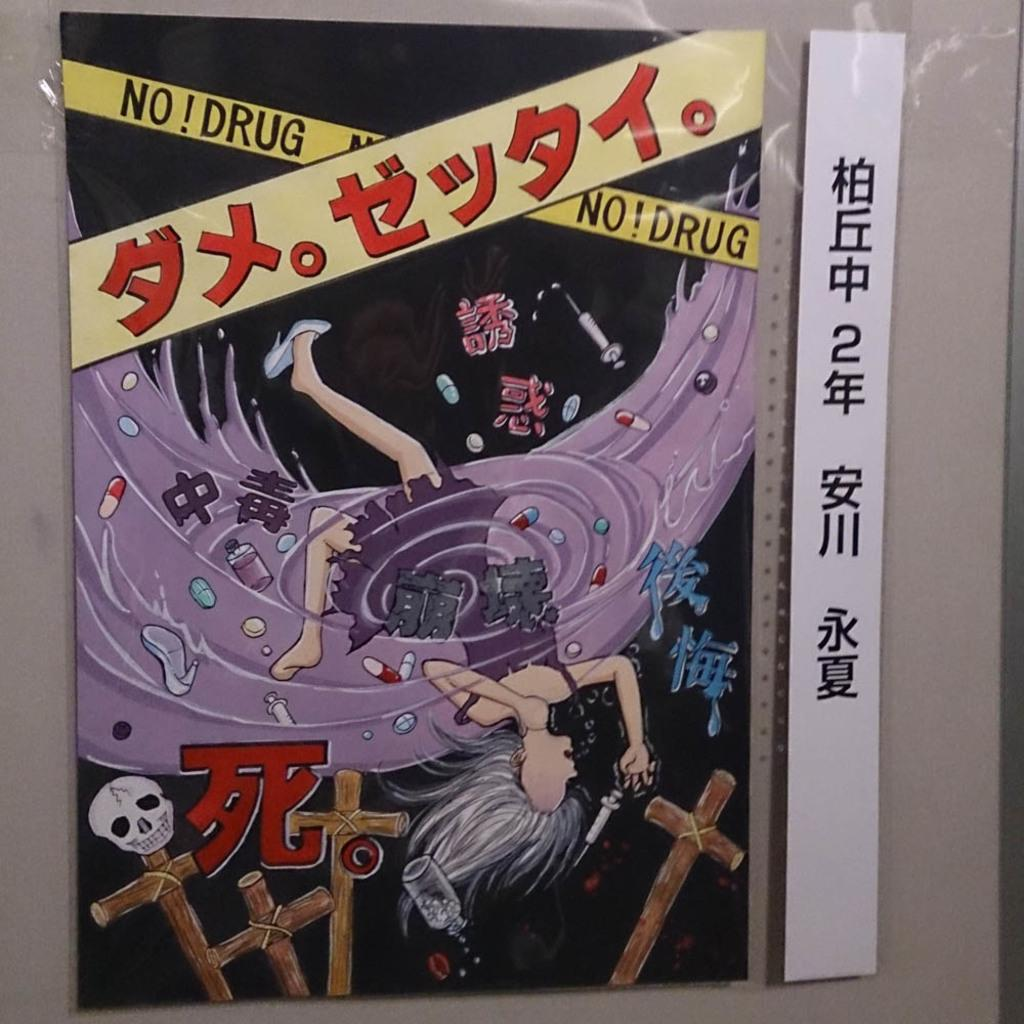<image>
Render a clear and concise summary of the photo. No Drug No Drug label on a chinese paper with a white ruler on the side. 